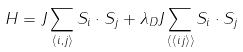<formula> <loc_0><loc_0><loc_500><loc_500>H = J \sum _ { \langle i , j \rangle } { S } _ { i } \cdot { S } _ { j } + \lambda _ { D } J \sum _ { \langle \langle i j \rangle \rangle } { S } _ { i } \cdot { S } _ { j }</formula> 